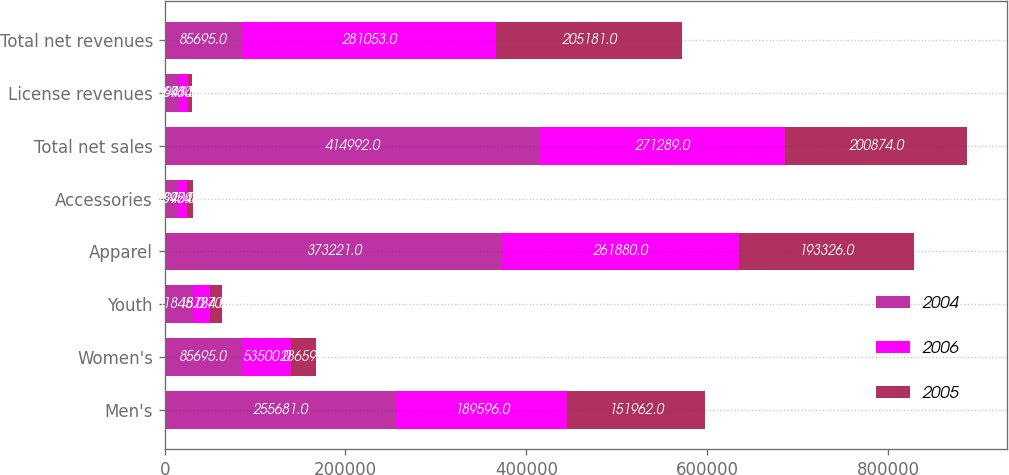Convert chart to OTSL. <chart><loc_0><loc_0><loc_500><loc_500><stacked_bar_chart><ecel><fcel>Men's<fcel>Women's<fcel>Youth<fcel>Apparel<fcel>Accessories<fcel>Total net sales<fcel>License revenues<fcel>Total net revenues<nl><fcel>2004<fcel>255681<fcel>85695<fcel>31845<fcel>373221<fcel>14897<fcel>414992<fcel>15697<fcel>85695<nl><fcel>2006<fcel>189596<fcel>53500<fcel>18784<fcel>261880<fcel>9409<fcel>271289<fcel>9764<fcel>281053<nl><fcel>2005<fcel>151962<fcel>28659<fcel>12705<fcel>193326<fcel>7548<fcel>200874<fcel>4307<fcel>205181<nl></chart> 